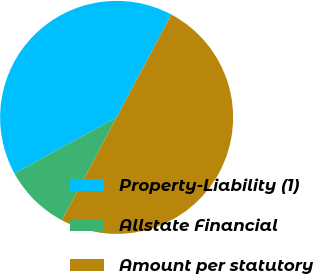Convert chart. <chart><loc_0><loc_0><loc_500><loc_500><pie_chart><fcel>Property-Liability (1)<fcel>Allstate Financial<fcel>Amount per statutory<nl><fcel>40.77%<fcel>9.23%<fcel>50.0%<nl></chart> 